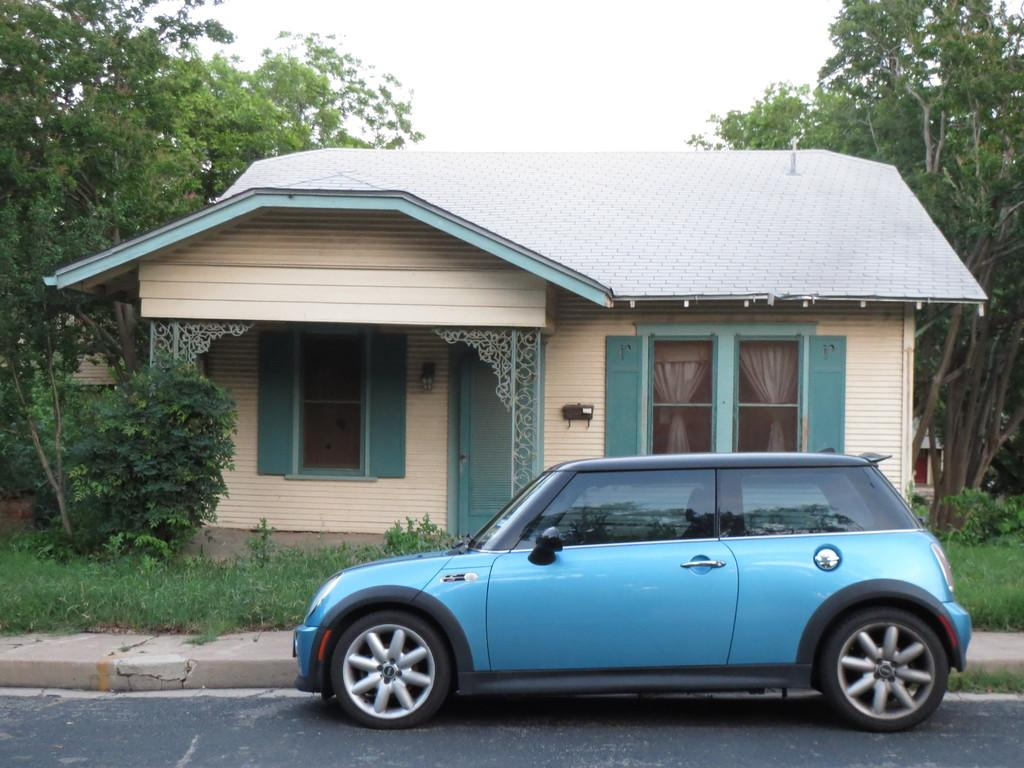What is the main subject of the image? The main subject of the image is a car. What can be seen in the background of the image? There is a road, grass, a house, trees, and the sky visible in the image. What type of terrain is visible in the image? The image shows a combination of road, grass, and trees, suggesting a mix of urban and natural environments. What type of cherry is being used to teach the banana in the image? There is no cherry or banana present in the image, and therefore no such teaching activity can be observed. 